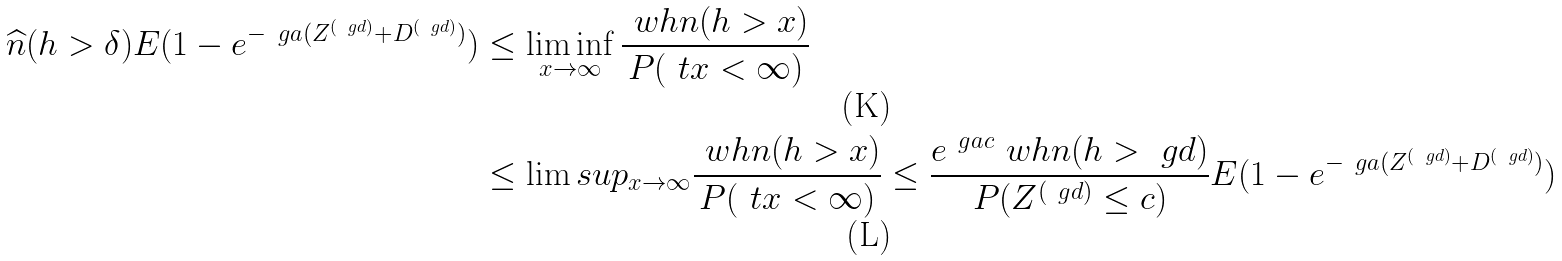<formula> <loc_0><loc_0><loc_500><loc_500>\widehat { n } ( h > \delta ) E ( 1 - e ^ { - \ g a ( Z ^ { ( \ g d ) } + D ^ { ( \ g d ) } ) } ) & \leq \liminf _ { x \to \infty } \frac { \ w h n ( h > x ) } { P ( \ t x < \infty ) } \\ & \leq \lim s u p _ { x \to \infty } \frac { \ w h n ( h > x ) } { P ( \ t x < \infty ) } \leq \frac { e ^ { \ g a c } \ w h n ( h > \ g d ) } { P ( Z ^ { ( \ g d ) } \leq c ) } E ( 1 - e ^ { - \ g a ( Z ^ { ( \ g d ) } + D ^ { ( \ g d ) } ) } )</formula> 